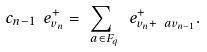<formula> <loc_0><loc_0><loc_500><loc_500>c _ { n - 1 } \ e ^ { + } _ { v _ { n } } = \sum _ { \ a \in F _ { q } } \ e ^ { + } _ { v _ { n } + \ a v _ { n - 1 } } .</formula> 